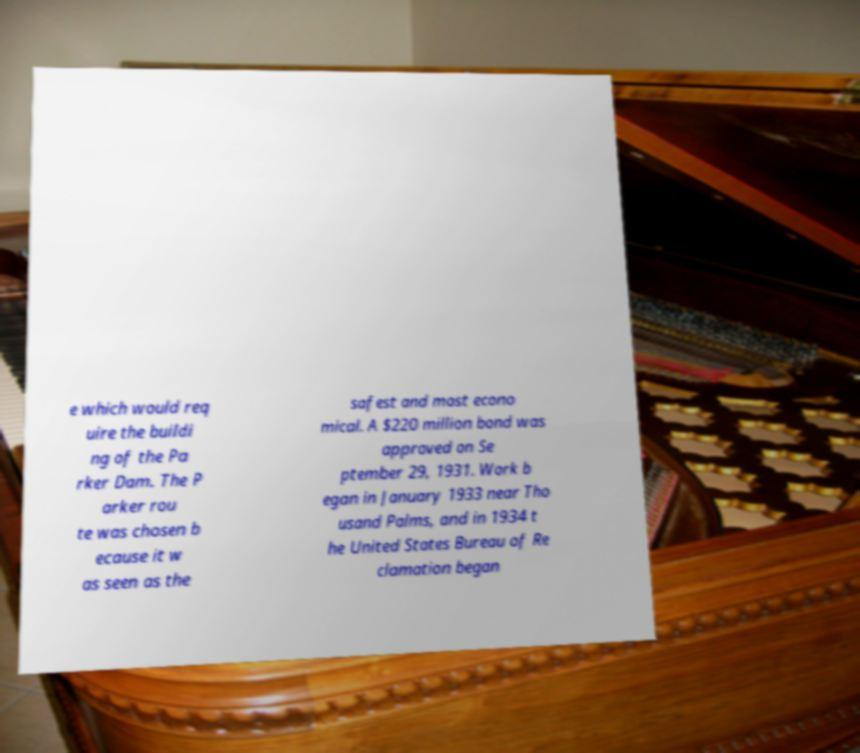Can you read and provide the text displayed in the image?This photo seems to have some interesting text. Can you extract and type it out for me? e which would req uire the buildi ng of the Pa rker Dam. The P arker rou te was chosen b ecause it w as seen as the safest and most econo mical. A $220 million bond was approved on Se ptember 29, 1931. Work b egan in January 1933 near Tho usand Palms, and in 1934 t he United States Bureau of Re clamation began 